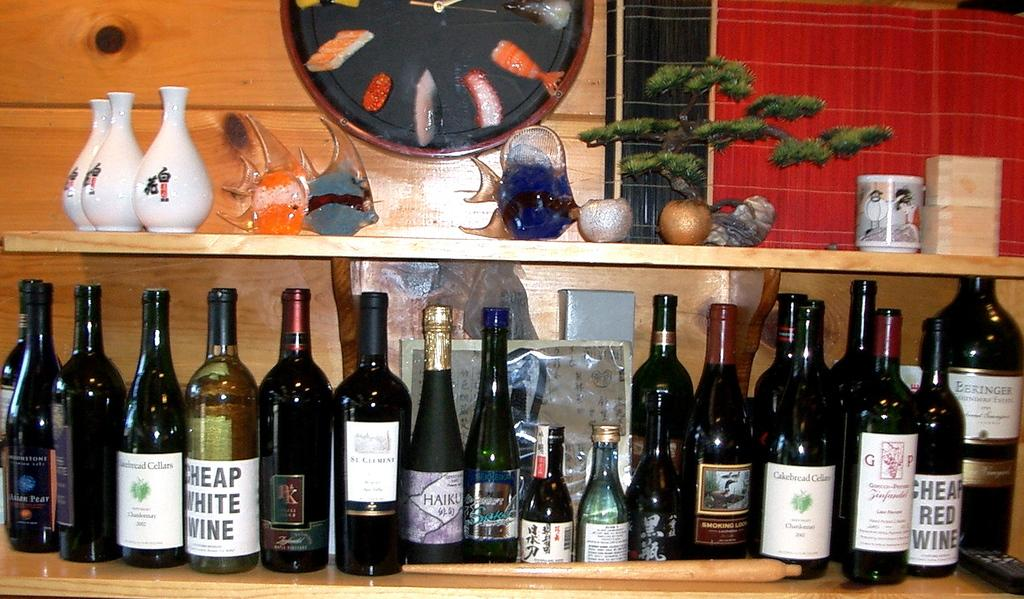<image>
Describe the image concisely. A stand with several bottles of alcoholic beverages including one called cheap white wine. 